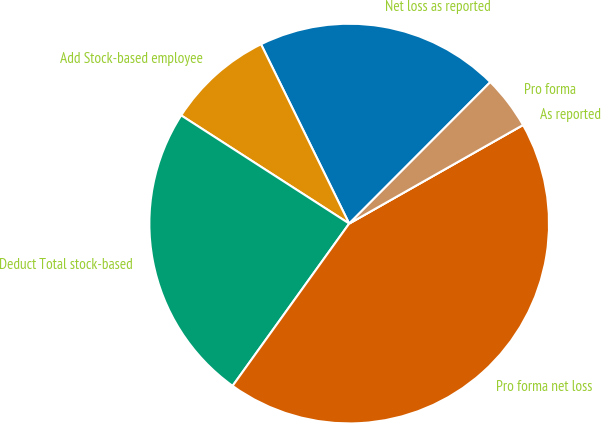Convert chart. <chart><loc_0><loc_0><loc_500><loc_500><pie_chart><fcel>Net loss as reported<fcel>Add Stock-based employee<fcel>Deduct Total stock-based<fcel>Pro forma net loss<fcel>As reported<fcel>Pro forma<nl><fcel>19.75%<fcel>8.62%<fcel>24.19%<fcel>43.12%<fcel>0.0%<fcel>4.31%<nl></chart> 